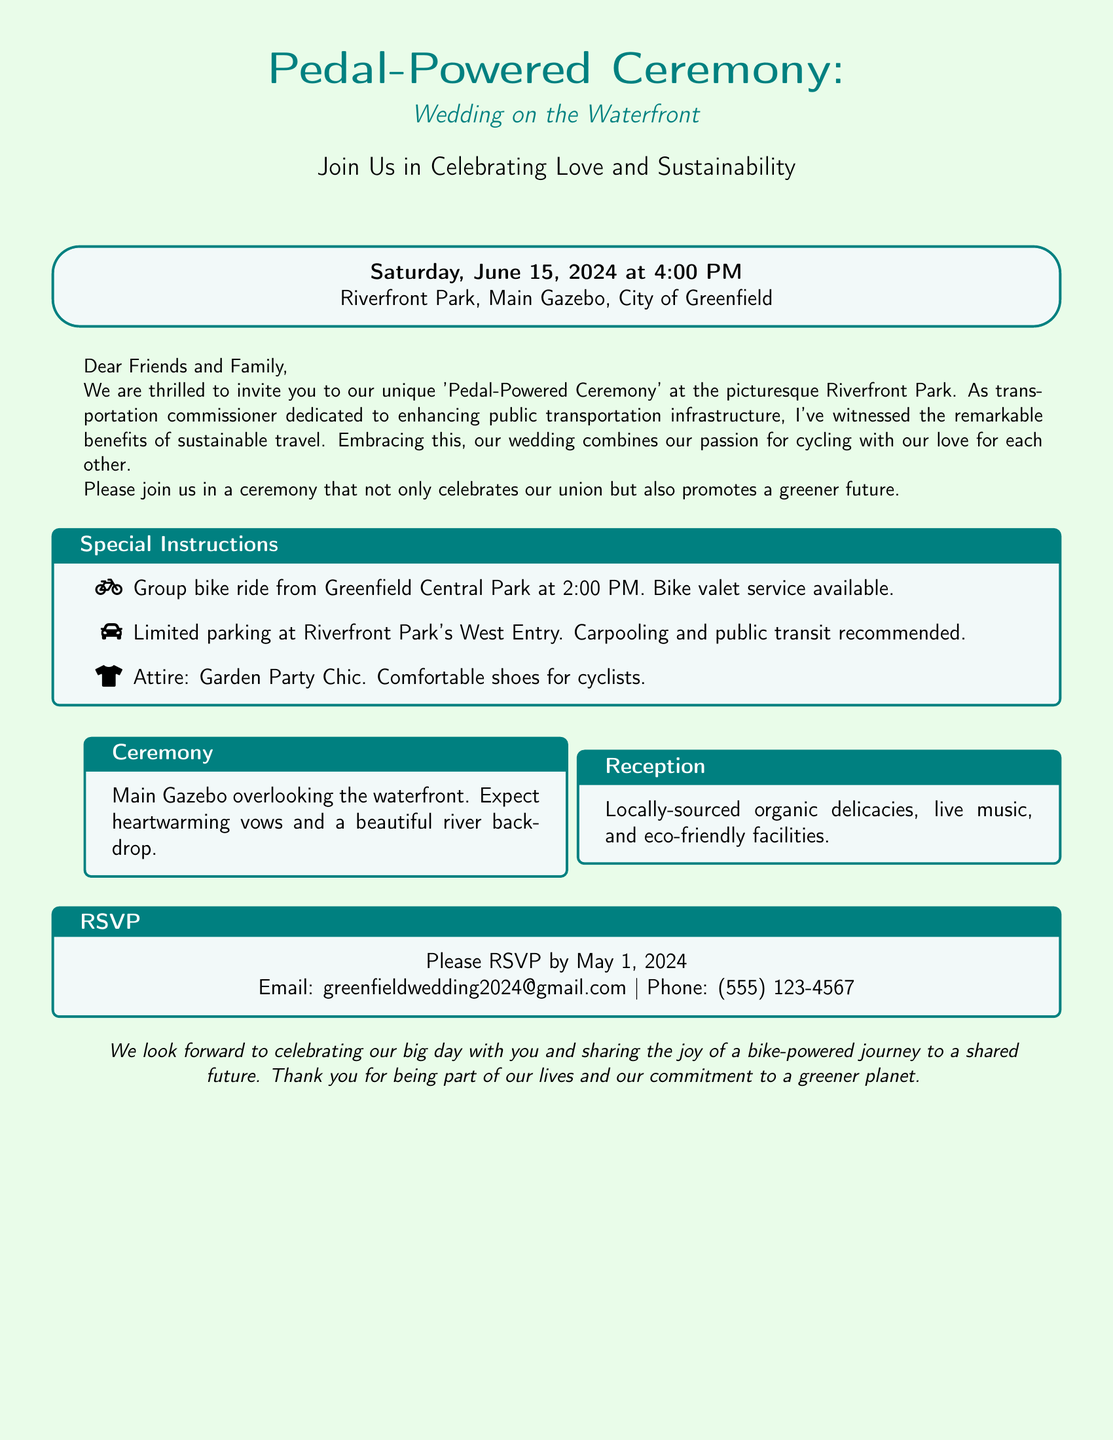What is the wedding date? The wedding date is specified in the document as Saturday, June 15, 2024.
Answer: June 15, 2024 Where is the ceremony taking place? The ceremony location is provided in the document as Riverfront Park, Main Gazebo, City of Greenfield.
Answer: Riverfront Park, Main Gazebo, City of Greenfield What time does the wedding start? The starting time of the wedding is given in the document as 4:00 PM.
Answer: 4:00 PM What type of ride is organized before the ceremony? The document mentions a group bike ride planned from Greenfield Central Park.
Answer: Group bike ride What is encouraged for attendees' attire? The recommended attire for the wedding is described as Garden Party Chic in the document.
Answer: Garden Party Chic How can guests respond to the invitation? The RSVP details explain that guests can respond via email or phone.
Answer: Email or phone What is the main focus of the wedding celebration? The document highlights the wedding celebration’s emphasis on both love and sustainability.
Answer: Love and sustainability What type of food will be served at the reception? The document specifies that the reception will feature locally-sourced organic delicacies.
Answer: Locally-sourced organic delicacies 